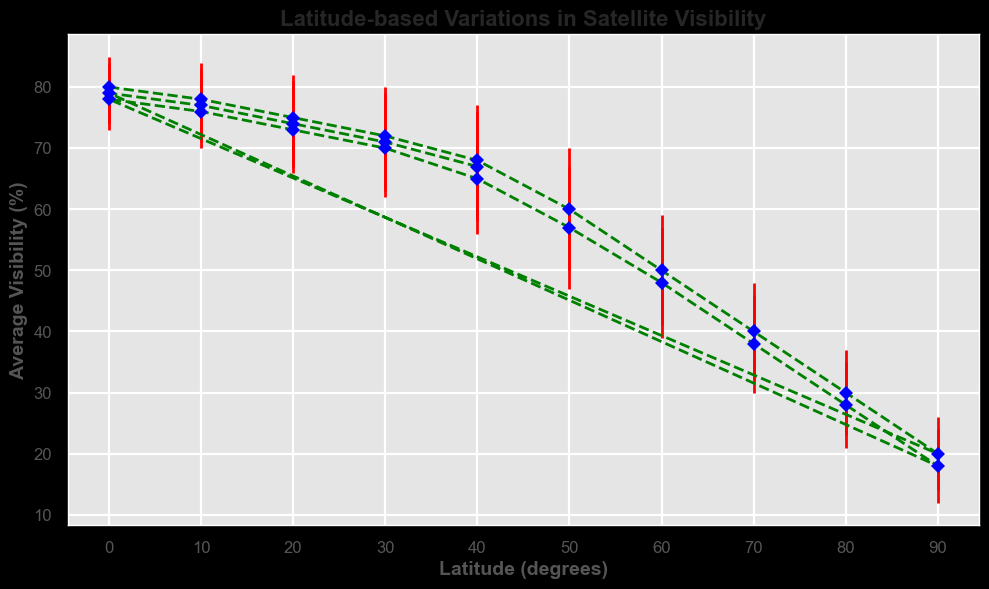What is the maximum average visibility shown on the chart? The highest point on the vertical axis of the chart representing average visibility is at Latitude 0 degrees between 00:00 and 01:00, which is 80%.
Answer: 80% Which latitude has the lowest average visibility? The lowest point on the vertical axis of the chart representing average visibility is at Latitude 90 degrees at 18:00, which is 18%.
Answer: 18% Is the average visibility at Latitude 50 higher at 05:00 or 15:00? At Latitude 50 degrees, the average visibility at 05:00 is 60%, and at 15:00 it is 57%. Comparing these, 60% is higher than 57%.
Answer: 05:00 What is the average visibility at Latitude 40 and what is its corresponding error margin? At Latitude 40, the chart shows two time points (04:00, 24:00 and 14:00), all with the same visibility of 68%, 67%, and 65%. The error margin is 9% in both cases.
Answer: 68%, 9% What is the trend of average visibility from latitude 0 to latitude 90? As you move from 0 degrees to 90 degrees latitude, the average visibility generally decreases.
Answer: Decreasing trend How many data points have an average visibility higher than 70%? Examining the chart, we see that points corresponding to latitudes 0, 10, 20, and 30 have average visibilities above 70% (80, 78, 78, 77, 76, 75). There are a total of 6 such data points.
Answer: 6 points Which interval of latitude sees the largest drop in visibility according to the chart? By analyzing the chart, the largest drop in visibility is from Latitude 40 to Latitude 50, where visibility drops from 68% to 60%.
Answer: 40 to 50 degrees At which two latitudes do the error margins appear visually the largest? The latitudes with the largest error margins, according to the lengths of the error bars on the chart, are at Latitude 50 (10%) and 60 (10%).
Answer: 50 and 60 degrees 